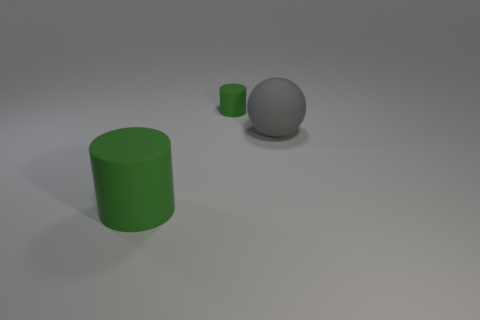Is the large object that is to the right of the big cylinder made of the same material as the green cylinder that is to the right of the big cylinder?
Give a very brief answer. Yes. How many large gray matte balls are there?
Your response must be concise. 1. What number of large gray objects are the same shape as the small object?
Offer a terse response. 0. Is the tiny thing the same shape as the large gray matte thing?
Provide a succinct answer. No. What size is the rubber sphere?
Keep it short and to the point. Large. How many other gray balls have the same size as the rubber sphere?
Give a very brief answer. 0. Do the green matte cylinder that is behind the large green matte object and the rubber thing in front of the large gray rubber object have the same size?
Offer a terse response. No. What is the shape of the green thing behind the ball?
Ensure brevity in your answer.  Cylinder. The large green object that is on the left side of the green cylinder behind the big green rubber cylinder is made of what material?
Offer a very short reply. Rubber. Is there a rubber ball that has the same color as the large rubber cylinder?
Provide a short and direct response. No. 